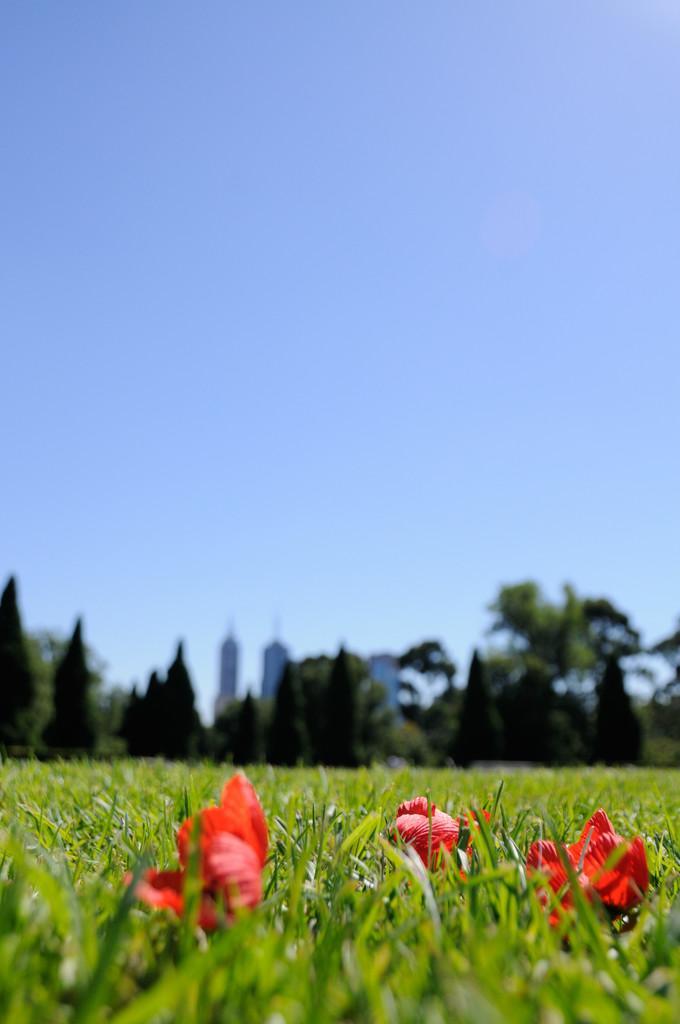How would you summarize this image in a sentence or two? In this image we can see the red color flowers on the grass. The background of the image is blurred, where we can see trees, tower buildings and the blue color sky. 